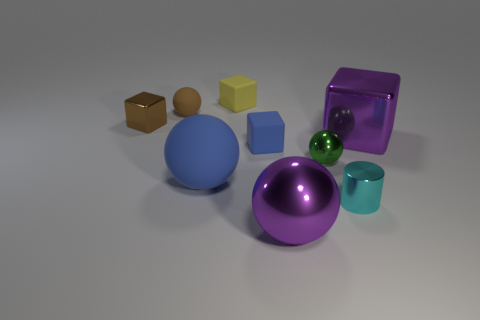Do the large metal thing that is on the left side of the tiny cyan cylinder and the matte thing that is left of the big blue matte sphere have the same shape? yes 